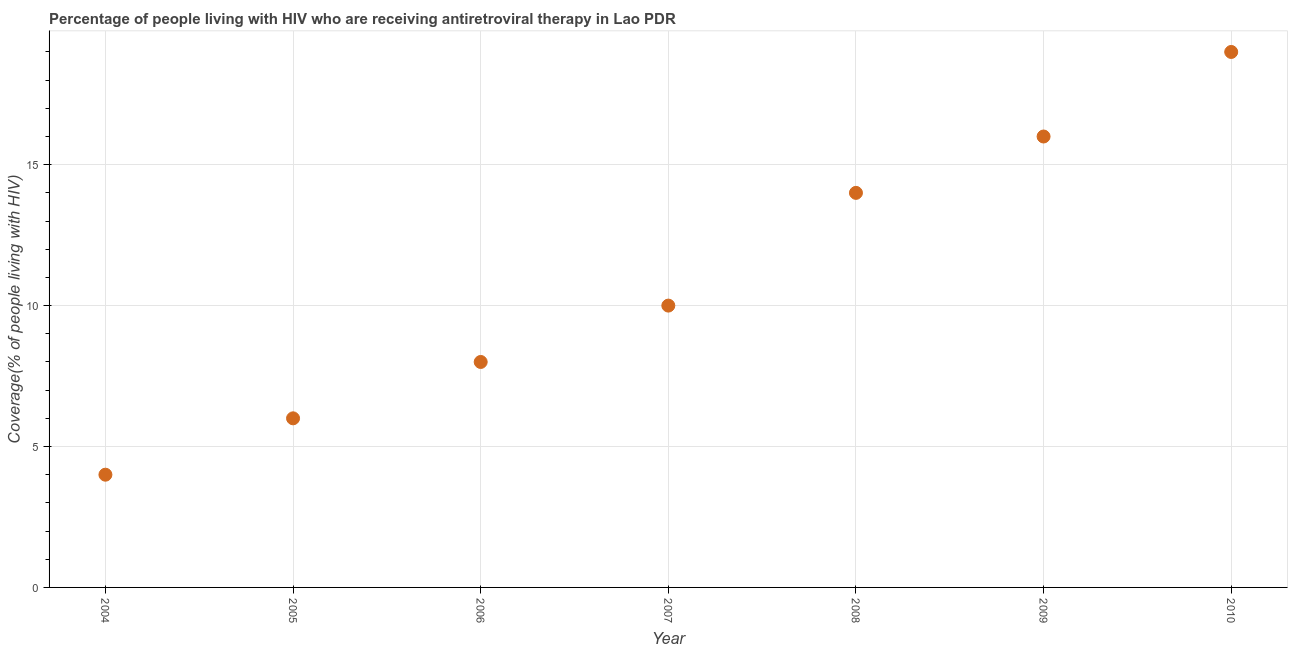What is the antiretroviral therapy coverage in 2008?
Provide a short and direct response. 14. Across all years, what is the maximum antiretroviral therapy coverage?
Provide a short and direct response. 19. Across all years, what is the minimum antiretroviral therapy coverage?
Ensure brevity in your answer.  4. In which year was the antiretroviral therapy coverage minimum?
Provide a succinct answer. 2004. What is the sum of the antiretroviral therapy coverage?
Give a very brief answer. 77. What is the difference between the antiretroviral therapy coverage in 2005 and 2008?
Ensure brevity in your answer.  -8. In how many years, is the antiretroviral therapy coverage greater than 8 %?
Your answer should be very brief. 4. Is the antiretroviral therapy coverage in 2004 less than that in 2010?
Give a very brief answer. Yes. What is the difference between the highest and the second highest antiretroviral therapy coverage?
Your response must be concise. 3. Is the sum of the antiretroviral therapy coverage in 2009 and 2010 greater than the maximum antiretroviral therapy coverage across all years?
Offer a terse response. Yes. What is the difference between the highest and the lowest antiretroviral therapy coverage?
Provide a short and direct response. 15. In how many years, is the antiretroviral therapy coverage greater than the average antiretroviral therapy coverage taken over all years?
Ensure brevity in your answer.  3. How many dotlines are there?
Your answer should be compact. 1. What is the difference between two consecutive major ticks on the Y-axis?
Offer a terse response. 5. Does the graph contain any zero values?
Ensure brevity in your answer.  No. Does the graph contain grids?
Provide a short and direct response. Yes. What is the title of the graph?
Your response must be concise. Percentage of people living with HIV who are receiving antiretroviral therapy in Lao PDR. What is the label or title of the Y-axis?
Offer a very short reply. Coverage(% of people living with HIV). What is the Coverage(% of people living with HIV) in 2006?
Offer a very short reply. 8. What is the Coverage(% of people living with HIV) in 2008?
Offer a terse response. 14. What is the Coverage(% of people living with HIV) in 2010?
Offer a terse response. 19. What is the difference between the Coverage(% of people living with HIV) in 2004 and 2005?
Provide a succinct answer. -2. What is the difference between the Coverage(% of people living with HIV) in 2004 and 2008?
Give a very brief answer. -10. What is the difference between the Coverage(% of people living with HIV) in 2005 and 2006?
Ensure brevity in your answer.  -2. What is the difference between the Coverage(% of people living with HIV) in 2005 and 2007?
Provide a short and direct response. -4. What is the difference between the Coverage(% of people living with HIV) in 2005 and 2008?
Your answer should be compact. -8. What is the difference between the Coverage(% of people living with HIV) in 2005 and 2009?
Keep it short and to the point. -10. What is the difference between the Coverage(% of people living with HIV) in 2006 and 2008?
Keep it short and to the point. -6. What is the difference between the Coverage(% of people living with HIV) in 2007 and 2009?
Ensure brevity in your answer.  -6. What is the difference between the Coverage(% of people living with HIV) in 2007 and 2010?
Offer a terse response. -9. What is the difference between the Coverage(% of people living with HIV) in 2008 and 2009?
Ensure brevity in your answer.  -2. What is the ratio of the Coverage(% of people living with HIV) in 2004 to that in 2005?
Offer a terse response. 0.67. What is the ratio of the Coverage(% of people living with HIV) in 2004 to that in 2008?
Provide a succinct answer. 0.29. What is the ratio of the Coverage(% of people living with HIV) in 2004 to that in 2009?
Your answer should be compact. 0.25. What is the ratio of the Coverage(% of people living with HIV) in 2004 to that in 2010?
Offer a terse response. 0.21. What is the ratio of the Coverage(% of people living with HIV) in 2005 to that in 2006?
Offer a terse response. 0.75. What is the ratio of the Coverage(% of people living with HIV) in 2005 to that in 2007?
Offer a terse response. 0.6. What is the ratio of the Coverage(% of people living with HIV) in 2005 to that in 2008?
Your answer should be very brief. 0.43. What is the ratio of the Coverage(% of people living with HIV) in 2005 to that in 2010?
Provide a succinct answer. 0.32. What is the ratio of the Coverage(% of people living with HIV) in 2006 to that in 2008?
Offer a terse response. 0.57. What is the ratio of the Coverage(% of people living with HIV) in 2006 to that in 2010?
Keep it short and to the point. 0.42. What is the ratio of the Coverage(% of people living with HIV) in 2007 to that in 2008?
Provide a short and direct response. 0.71. What is the ratio of the Coverage(% of people living with HIV) in 2007 to that in 2010?
Offer a terse response. 0.53. What is the ratio of the Coverage(% of people living with HIV) in 2008 to that in 2009?
Your answer should be very brief. 0.88. What is the ratio of the Coverage(% of people living with HIV) in 2008 to that in 2010?
Offer a very short reply. 0.74. What is the ratio of the Coverage(% of people living with HIV) in 2009 to that in 2010?
Provide a short and direct response. 0.84. 